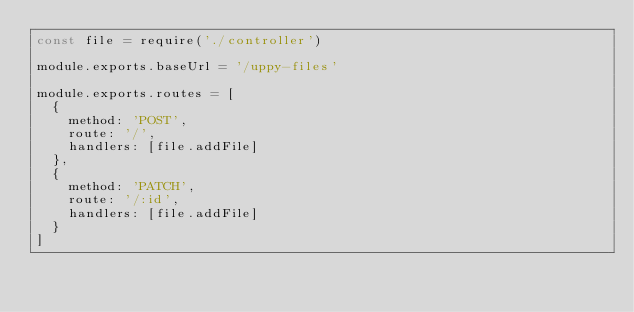<code> <loc_0><loc_0><loc_500><loc_500><_JavaScript_>const file = require('./controller')

module.exports.baseUrl = '/uppy-files'

module.exports.routes = [
  {
    method: 'POST',
    route: '/',
    handlers: [file.addFile]
  },
  {
    method: 'PATCH',
    route: '/:id',
    handlers: [file.addFile]
  }
]
</code> 